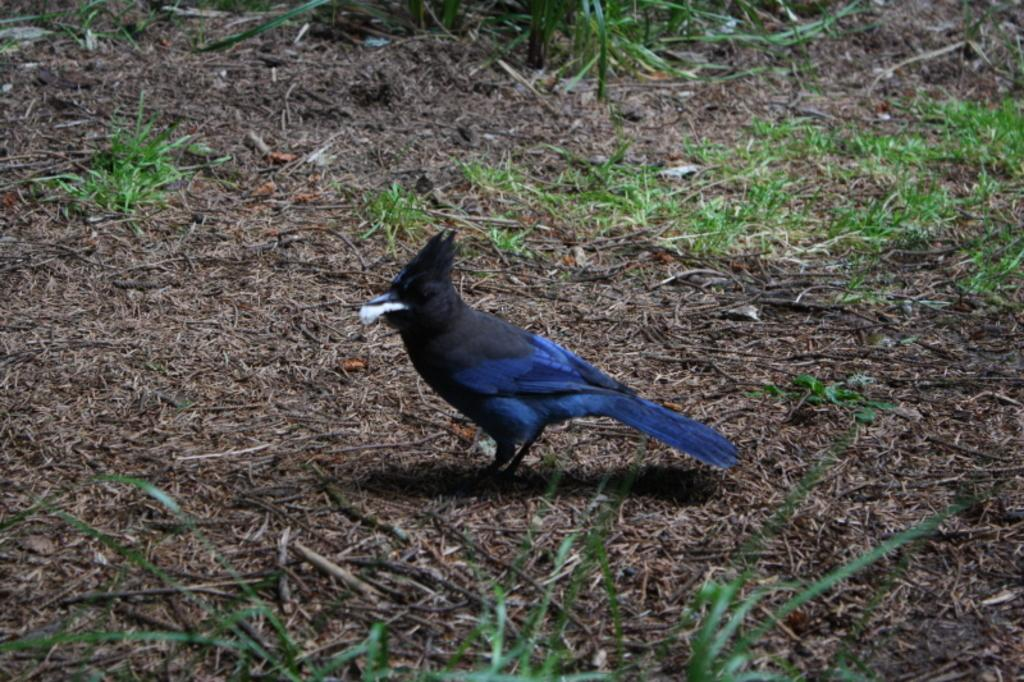What type of animal can be seen in the image? There is a bird in the image. Where is the bird located in the image? The bird is standing in the middle of the image. What colors can be seen on the bird? The bird is in black and blue color. What type of vegetation is visible in the image? There is grass in the image. Can you tell me how many mothers are present in the image? There are no people, including mothers, present in the image; it features a bird standing in the grass. What type of fish can be seen swimming in the image? There are no fish present in the image; it features a bird standing in the grass. 